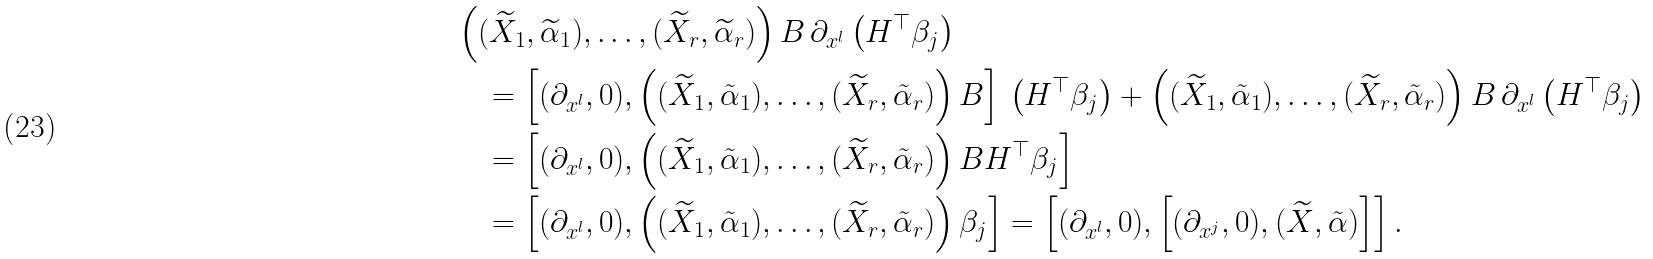Convert formula to latex. <formula><loc_0><loc_0><loc_500><loc_500>& \left ( ( \widetilde { X } _ { 1 } , \widetilde { \alpha } _ { 1 } ) , \dots , ( \widetilde { X } _ { r } , \widetilde { \alpha } _ { r } ) \right ) B \, \partial _ { x ^ { l } } \left ( H ^ { \top } \beta _ { j } \right ) \\ & \quad = \left [ ( \partial _ { x ^ { l } } , 0 ) , \left ( ( \widetilde { X } _ { 1 } , \tilde { \alpha } _ { 1 } ) , \dots , ( \widetilde { X } _ { r } , \tilde { \alpha } _ { r } ) \right ) B \right ] \, \left ( H ^ { \top } \beta _ { j } \right ) + \left ( ( \widetilde { X } _ { 1 } , \tilde { \alpha } _ { 1 } ) , \dots , ( \widetilde { X } _ { r } , \tilde { \alpha } _ { r } ) \right ) B \, \partial _ { x ^ { l } } \left ( H ^ { \top } \beta _ { j } \right ) \\ & \quad = \left [ ( \partial _ { x ^ { l } } , 0 ) , \left ( ( \widetilde { X } _ { 1 } , \tilde { \alpha } _ { 1 } ) , \dots , ( \widetilde { X } _ { r } , \tilde { \alpha } _ { r } ) \right ) B H ^ { \top } \beta _ { j } \right ] \\ & \quad = \left [ ( \partial _ { x ^ { l } } , 0 ) , \left ( ( \widetilde { X } _ { 1 } , \tilde { \alpha } _ { 1 } ) , \dots , ( \widetilde { X } _ { r } , \tilde { \alpha } _ { r } ) \right ) \beta _ { j } \right ] = \left [ ( \partial _ { x ^ { l } } , 0 ) , \left [ ( \partial _ { x ^ { j } } , 0 ) , ( \widetilde { X } , \tilde { \alpha } ) \right ] \right ] .</formula> 